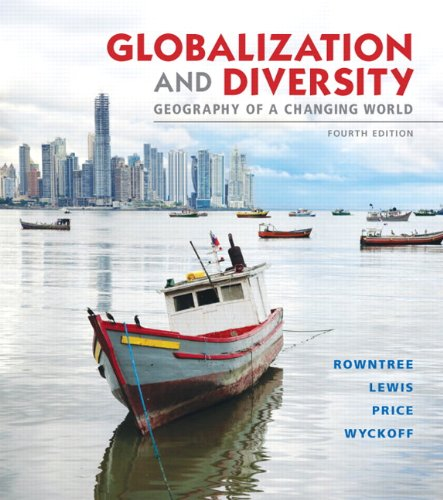Who is the author of this book? The primary author of the book is Lester Rowntree, but it also features contributions from Martin Lewis, Marie Price, and William Wyckoff. 